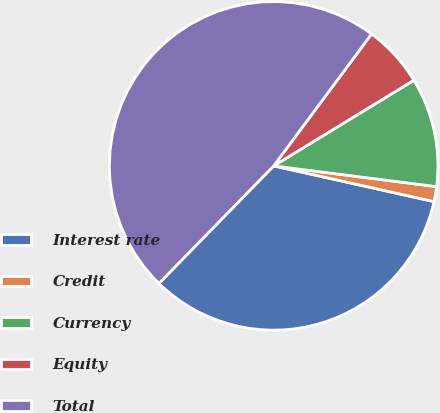<chart> <loc_0><loc_0><loc_500><loc_500><pie_chart><fcel>Interest rate<fcel>Credit<fcel>Currency<fcel>Equity<fcel>Total<nl><fcel>33.82%<fcel>1.47%<fcel>10.75%<fcel>6.11%<fcel>47.85%<nl></chart> 